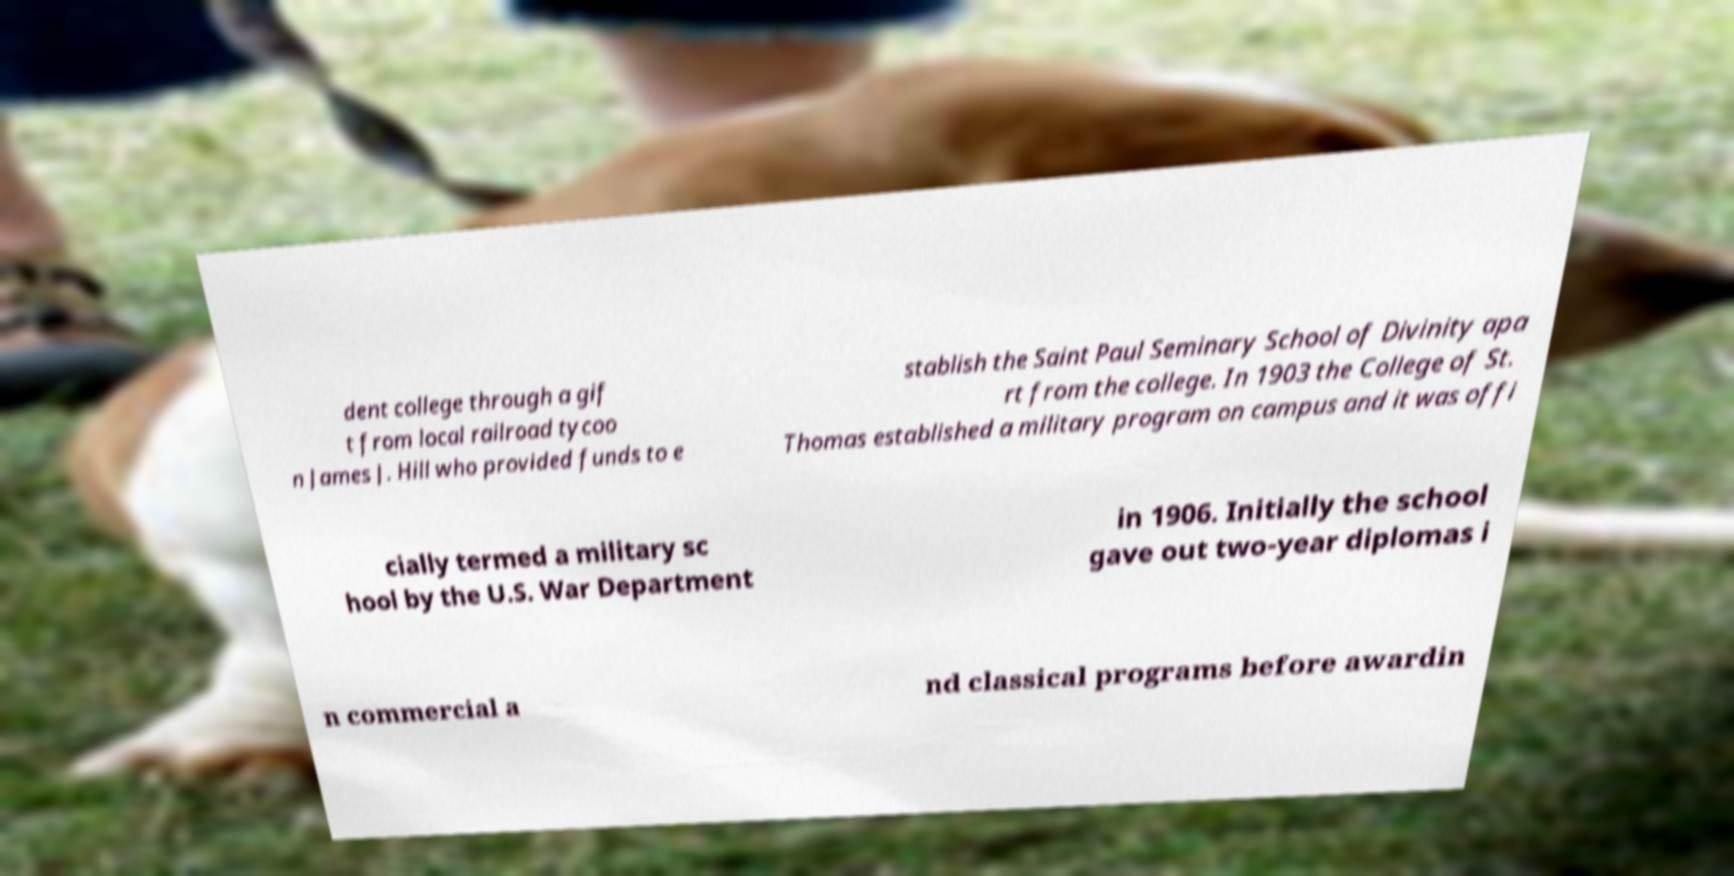Can you read and provide the text displayed in the image?This photo seems to have some interesting text. Can you extract and type it out for me? dent college through a gif t from local railroad tycoo n James J. Hill who provided funds to e stablish the Saint Paul Seminary School of Divinity apa rt from the college. In 1903 the College of St. Thomas established a military program on campus and it was offi cially termed a military sc hool by the U.S. War Department in 1906. Initially the school gave out two-year diplomas i n commercial a nd classical programs before awardin 